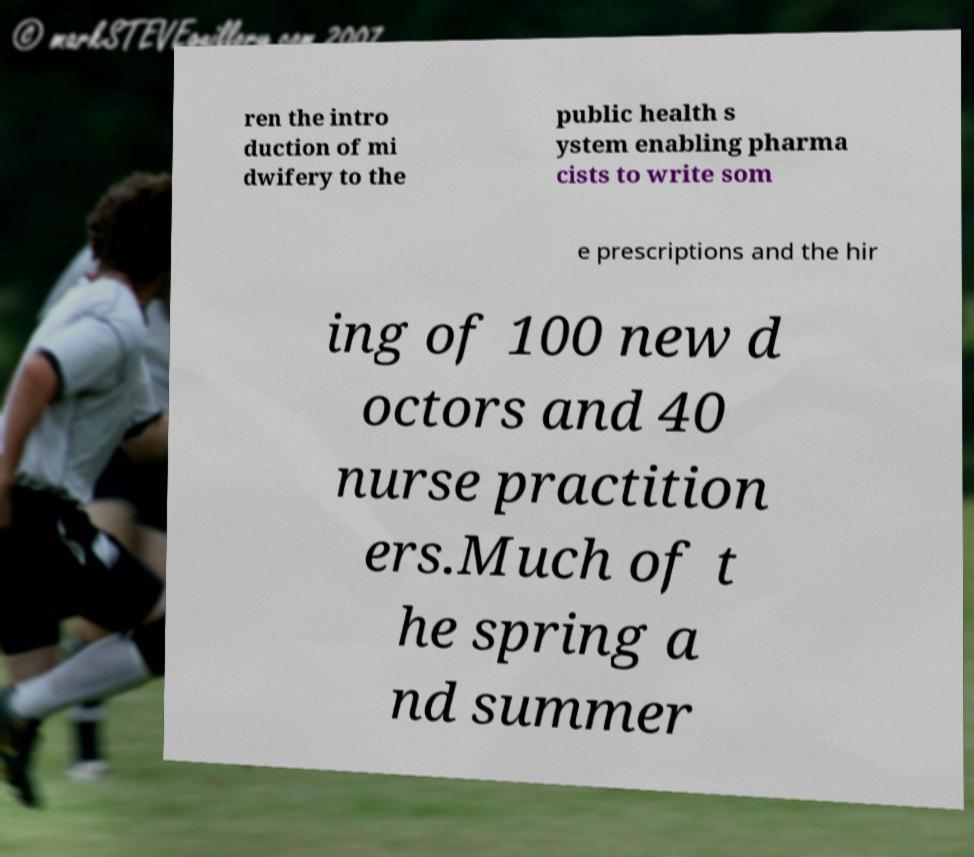I need the written content from this picture converted into text. Can you do that? ren the intro duction of mi dwifery to the public health s ystem enabling pharma cists to write som e prescriptions and the hir ing of 100 new d octors and 40 nurse practition ers.Much of t he spring a nd summer 